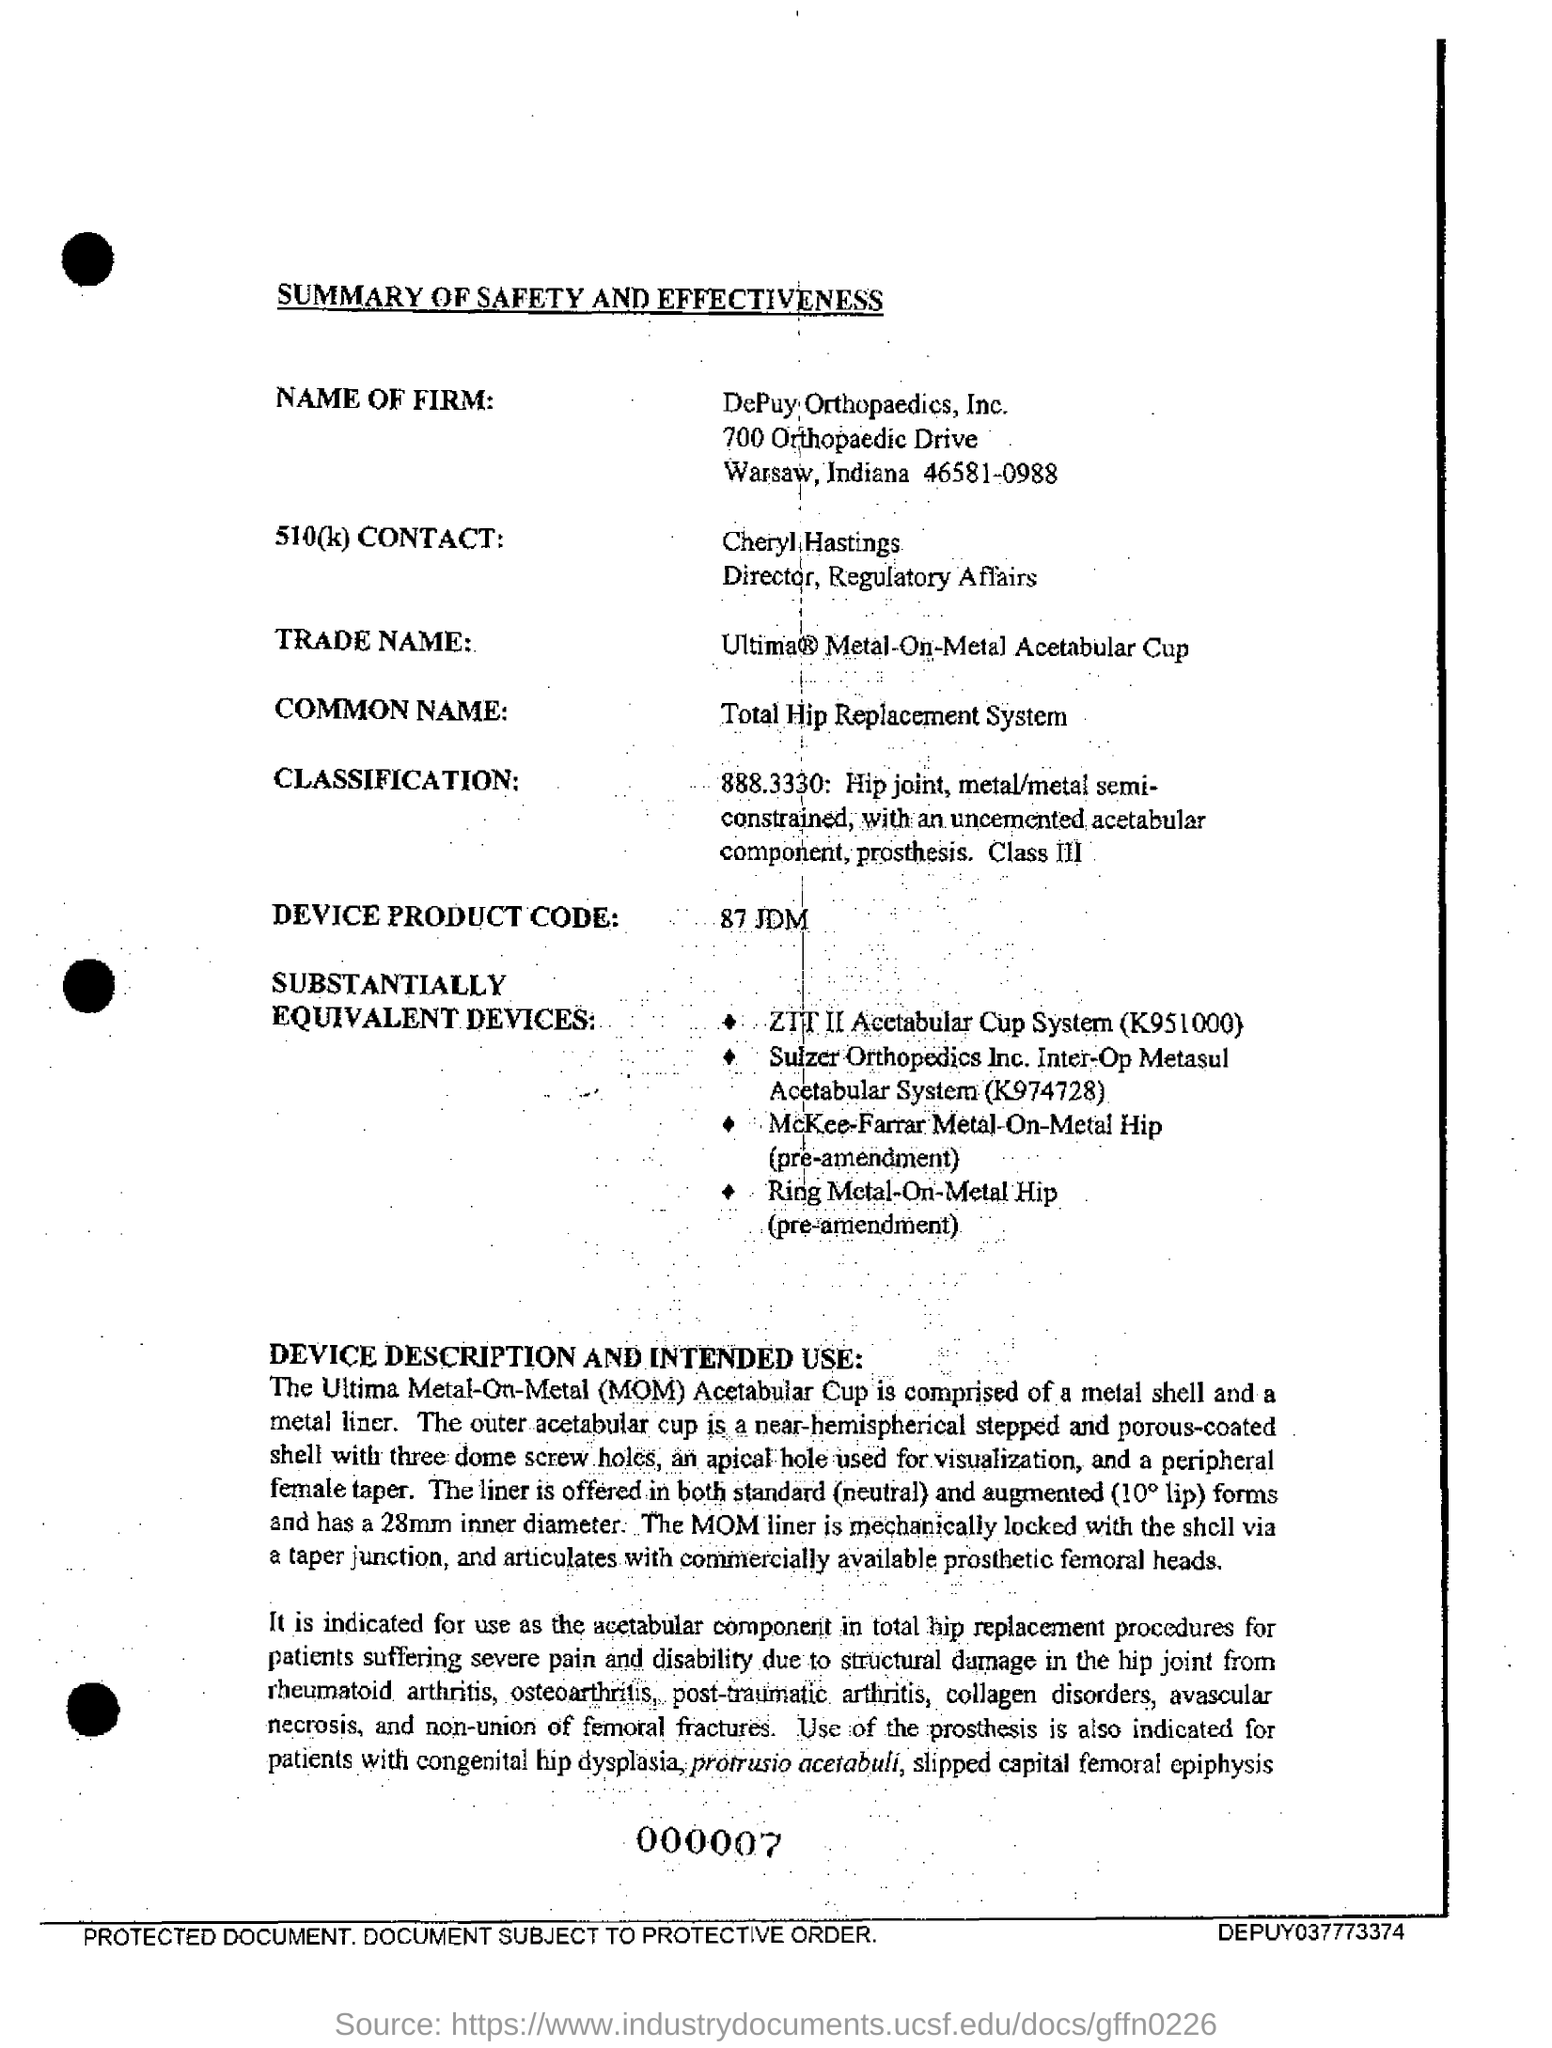Highlight a few significant elements in this photo. The document provides the name of the firm as Depuy Orthopaedics, Inc. The document mentions a common name, which is "Total Hip Replacement System". The full form of MOM is Metal-On-Metal. The title of the document is 'Summary of Safety and Effectiveness'. 